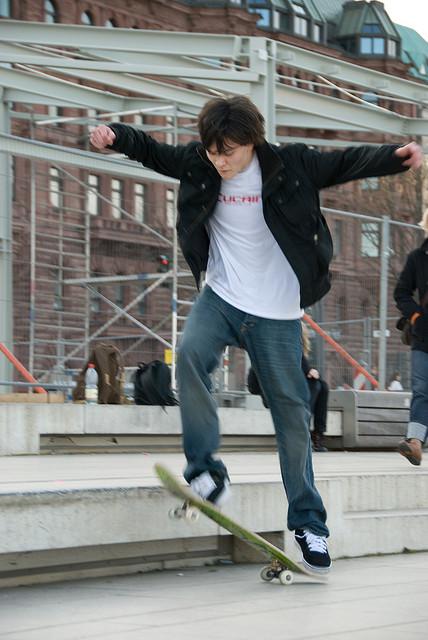What is the boy doing in the photo?
Write a very short answer. Skateboarding. What color is the boy's coat?
Give a very brief answer. Black. Is the boy moving?
Give a very brief answer. Yes. 